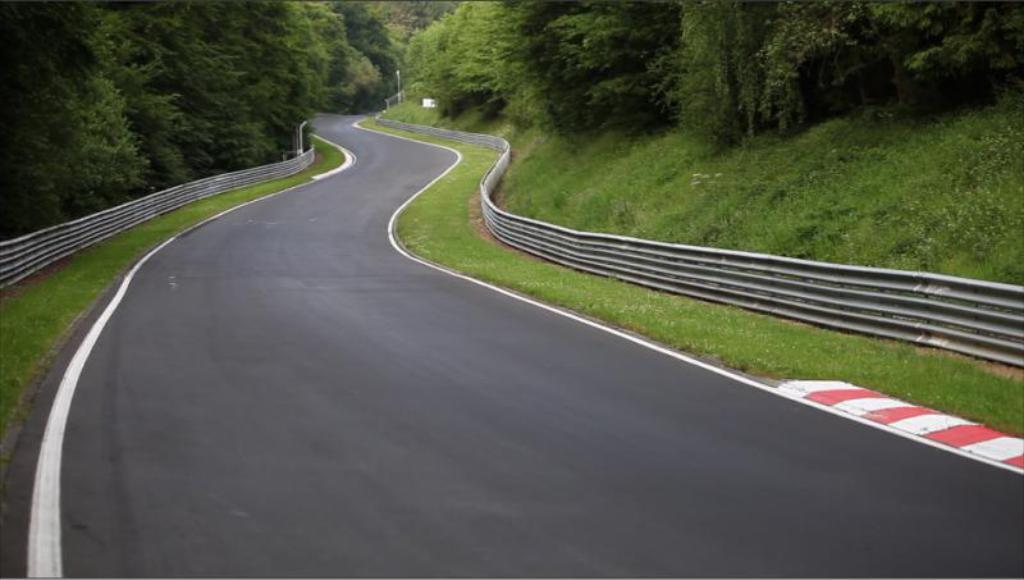What is the main feature of the image? There is a road in the image. What can be seen in the background of the image? There are trees and grass in the background of the image. What is the color of the trees and grass? The trees and grass are green in color. Can you describe any other objects in the image? There is a pole in the image. Can you see the partner of the giraffe in the image? There is no giraffe or its partner present in the image. What type of rod is being used to stir the grass in the image? There is no rod or stirring action involving the grass in the image. 